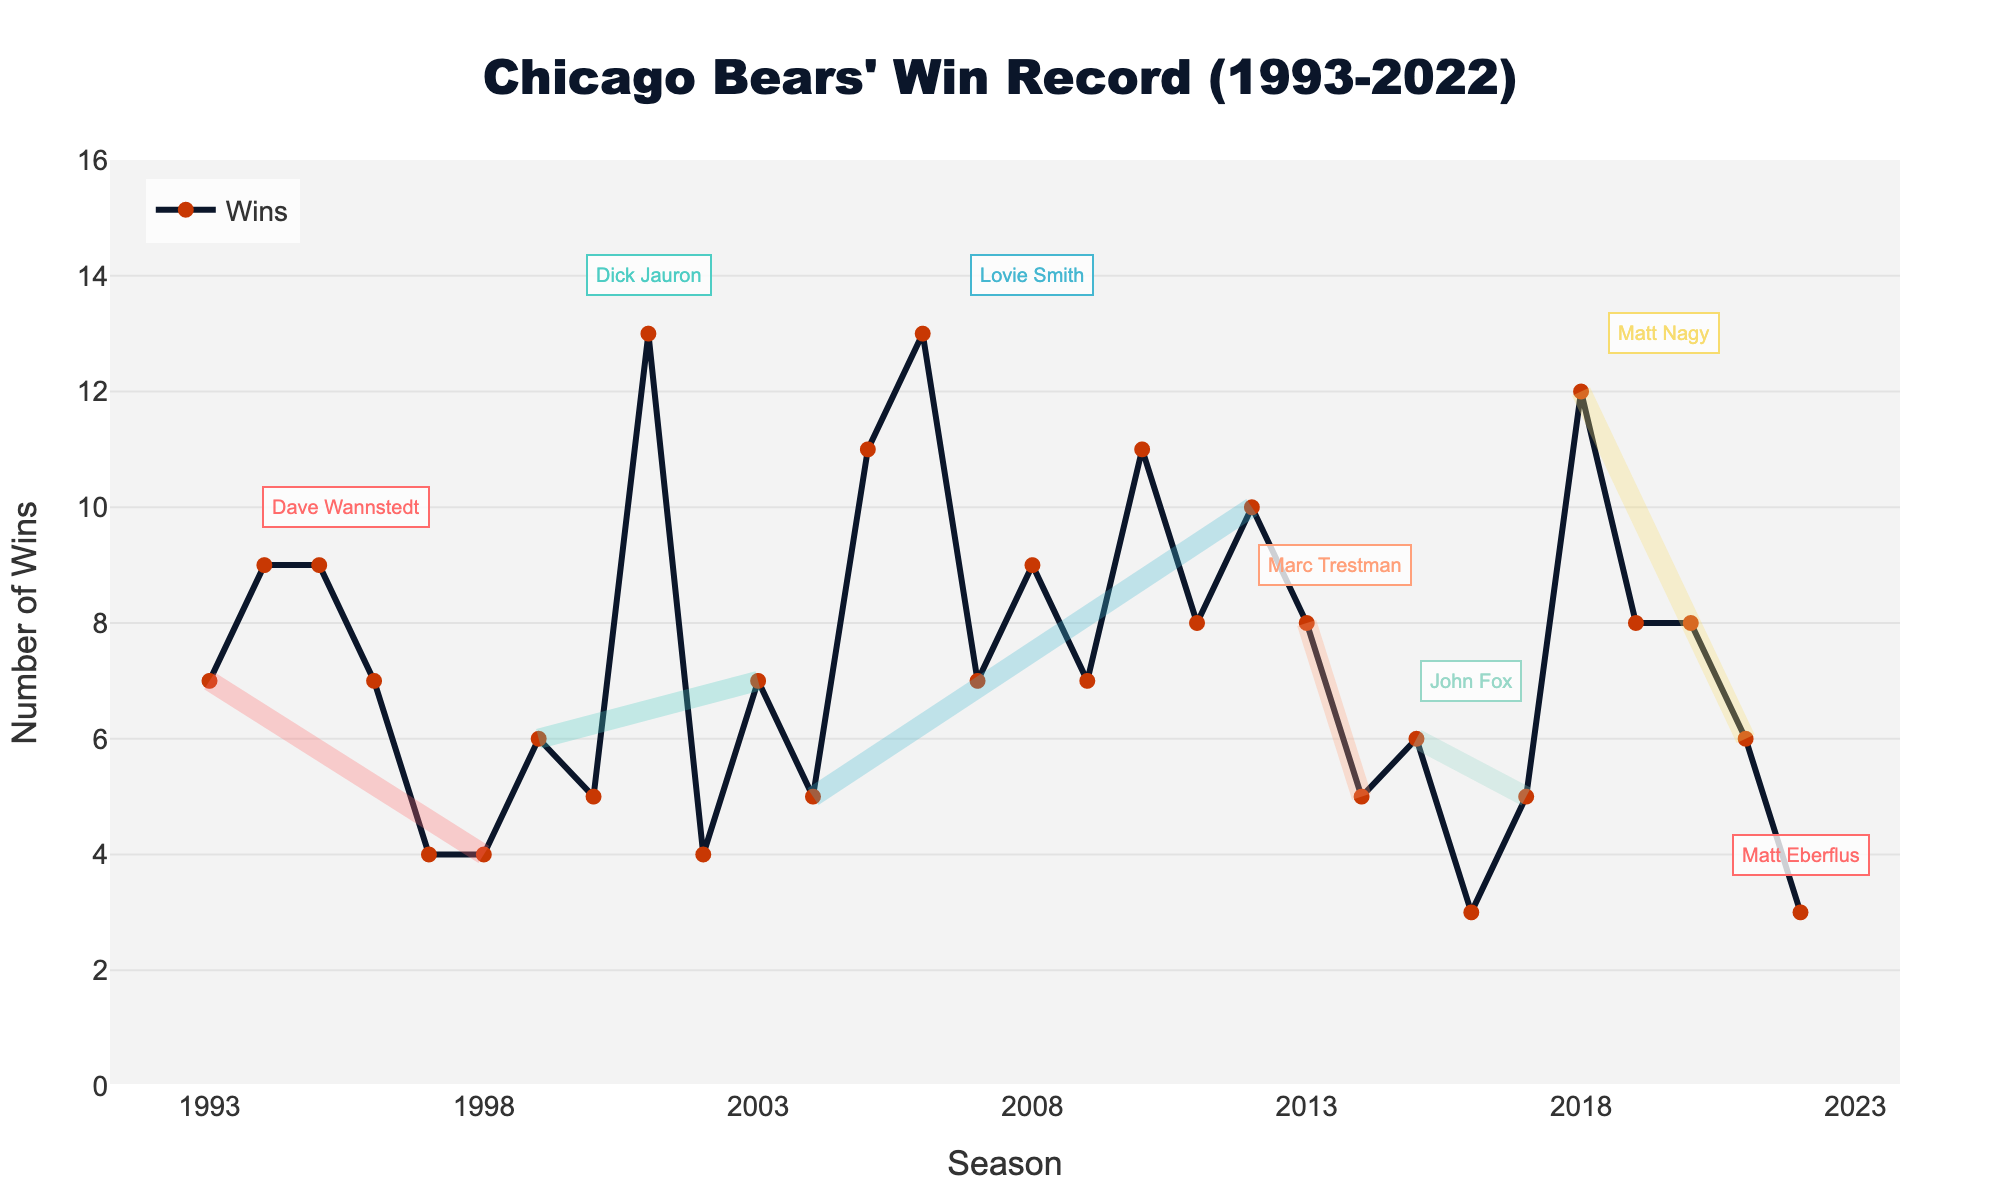What's the maximum number of wins in one season? To find the maximum number of wins in a single season, look for the highest point on the 'Wins' line in the chart and note the peak value.
Answer: 13 Which coach had the highest number of wins in one season? Identify the peak win count in the chart and check which coach's tenure that peak falls under.
Answer: Dick Jauron and Lovie Smith Between which seasons did the Chicago Bears have their biggest winning streak? Find the longest continuous upward trend in the 'Wins' line.
Answer: 2004 to 2006 How did the win-loss record change during Jay Cutler’s time with the team? Jay Cutler joined the Bears in 2009. Compare the 'Wins' line from 2009 to the end of Lovie Smith's tenure in 2012 to observe the variation.
Answer: It fluctuated from 7 to 10 wins Which coach had the most consistent number of wins over their entire tenure? Check the win lines and look for the coach whose tenure shows the least variation in wins.
Answer: Lovie Smith How many seasons did Lovie Smith have 10 or more wins? Count the number of seasons in Lovie Smith's tenure where the 'Wins' value is 10 or more.
Answer: 4 Who had a worse win record: Marc Trestman or John Fox? Compare the total number of wins during the tenures of Marc Trestman and John Fox by observing the height of their respective sections on the 'Wins' line.
Answer: John Fox What is the biggest decrease in wins from one season to the next? Find the steepest downward slope between two consecutive seasons in the 'Wins' line.
Answer: 2006 to 2007 (13 to 7 wins) How many times did the Bears finish a season with a .500 record (equal wins and losses)? Identify the seasons where the 'Wins' value equals the 'Losses' value.
Answer: 3 During whose tenure did the Bears have the lowest win count in a season, and what was it? Identify the lowest point on the 'Wins' line and match it to the coach's time span.
Answer: Matt Eberflus, 3 wins 